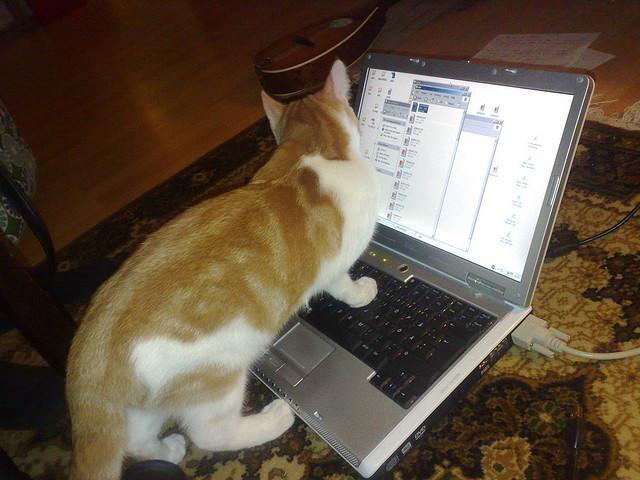How many people lack umbrellas?
Give a very brief answer. 0. 